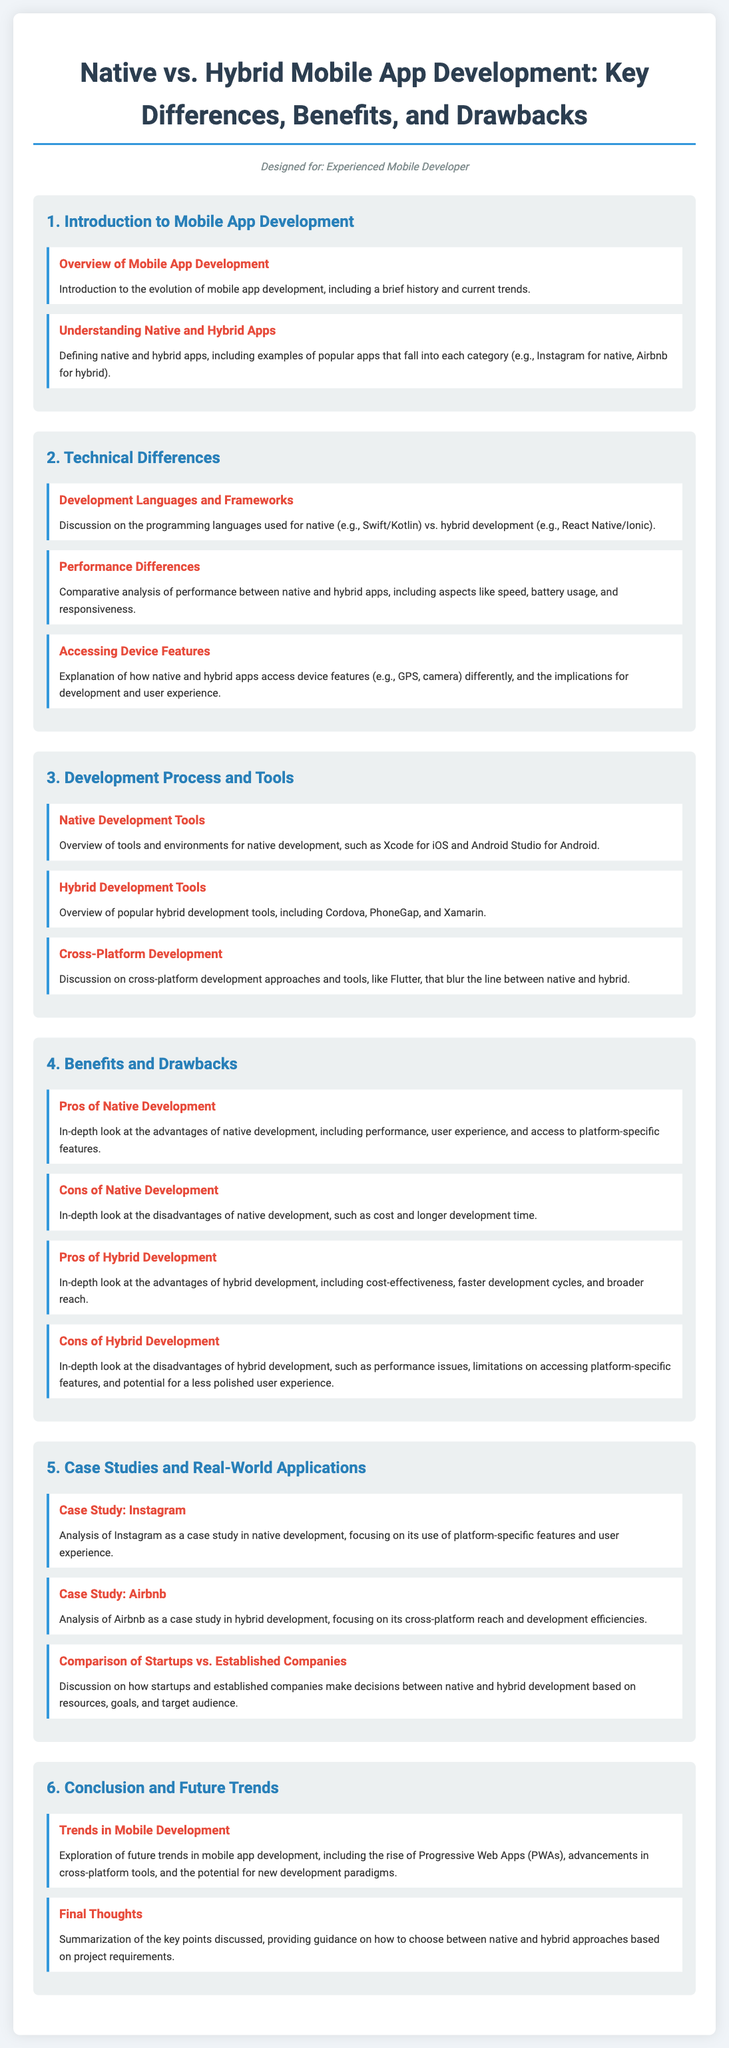What is the title of the syllabus? The title is prominently displayed at the top of the document and outlines the main focus of the syllabus.
Answer: Native vs. Hybrid Mobile App Development: Key Differences, Benefits, and Drawbacks Who is the syllabus designed for? The designed audience is mentioned in the introduction section, stating whom the document targets.
Answer: Experienced Mobile Developer Which module covers technical differences? The module titles are numbered, and the specific title indicates the topic it covers.
Answer: 2. Technical Differences What are the two types of app development discussed? This is outlined in the introduction section, where both types are explicitly mentioned.
Answer: Native and Hybrid What tool is mentioned for native development on iOS? The tools overview section lists specific tools for development environments, including one for iOS.
Answer: Xcode Name one advantage of native development. The advantages are discussed in-depth in the benefits and drawbacks module.
Answer: Performance Which company is used as a case study for hybrid development? The case study section provides examples relevant to each type of app development.
Answer: Airbnb What is one future trend in mobile development? The trends are explored in the conclusion module, revealing insights into upcoming changes.
Answer: Progressive Web Apps (PWAs) What is the main focus of the syllabus? The overall goal of the syllabus is described in the title and the introduction, summarizing what will be covered.
Answer: Key Differences, Benefits, and Drawbacks 